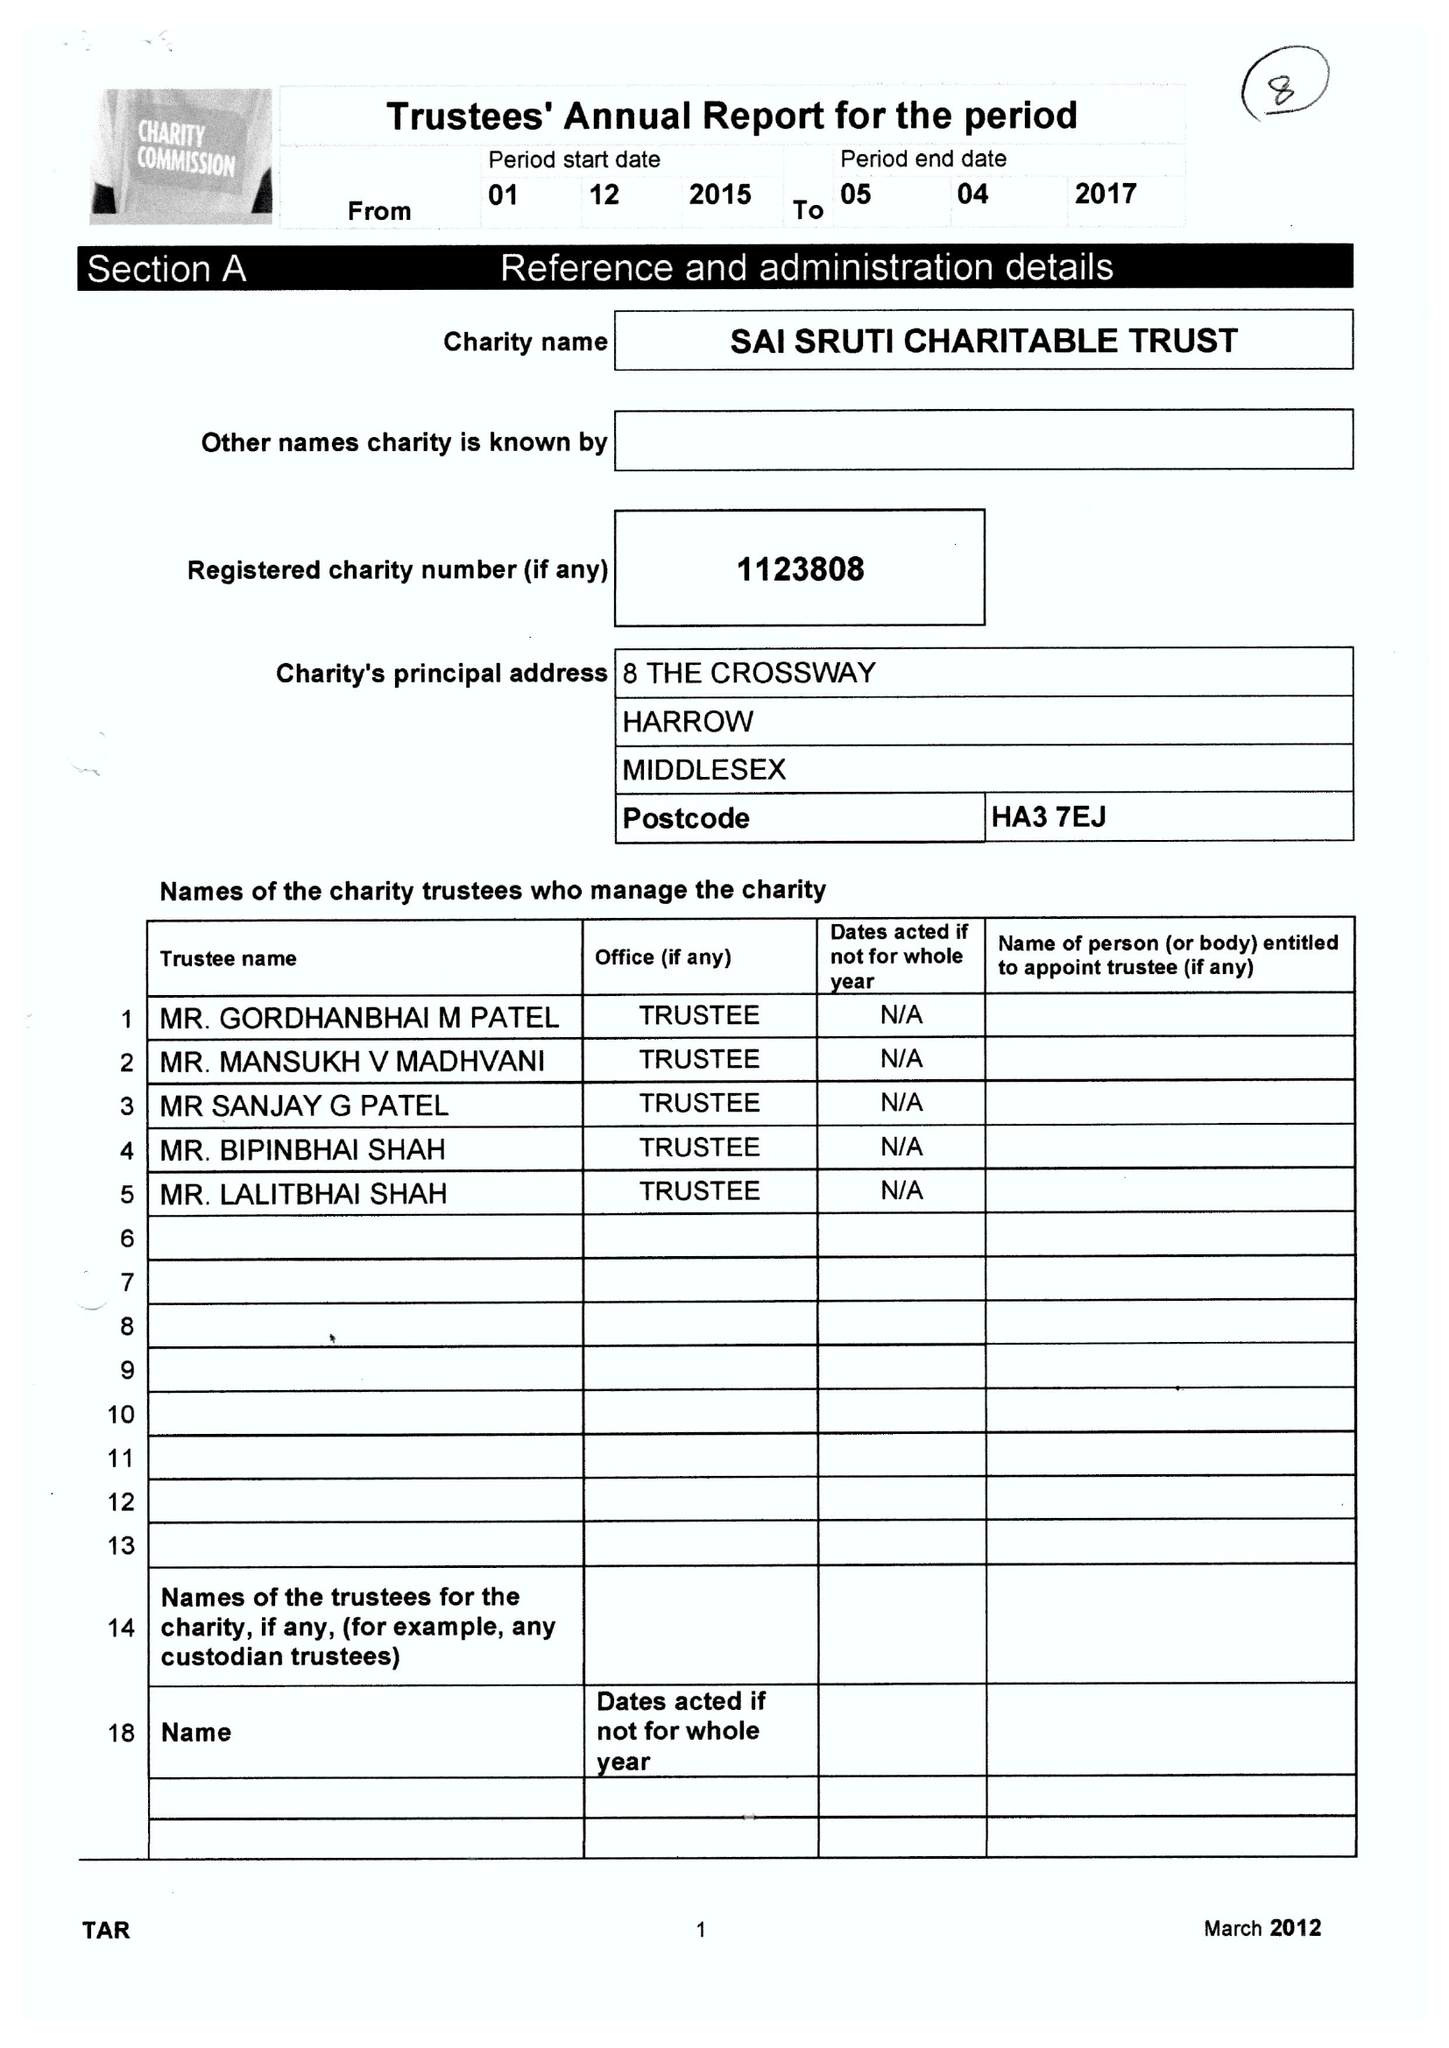What is the value for the report_date?
Answer the question using a single word or phrase. 2017-04-05 